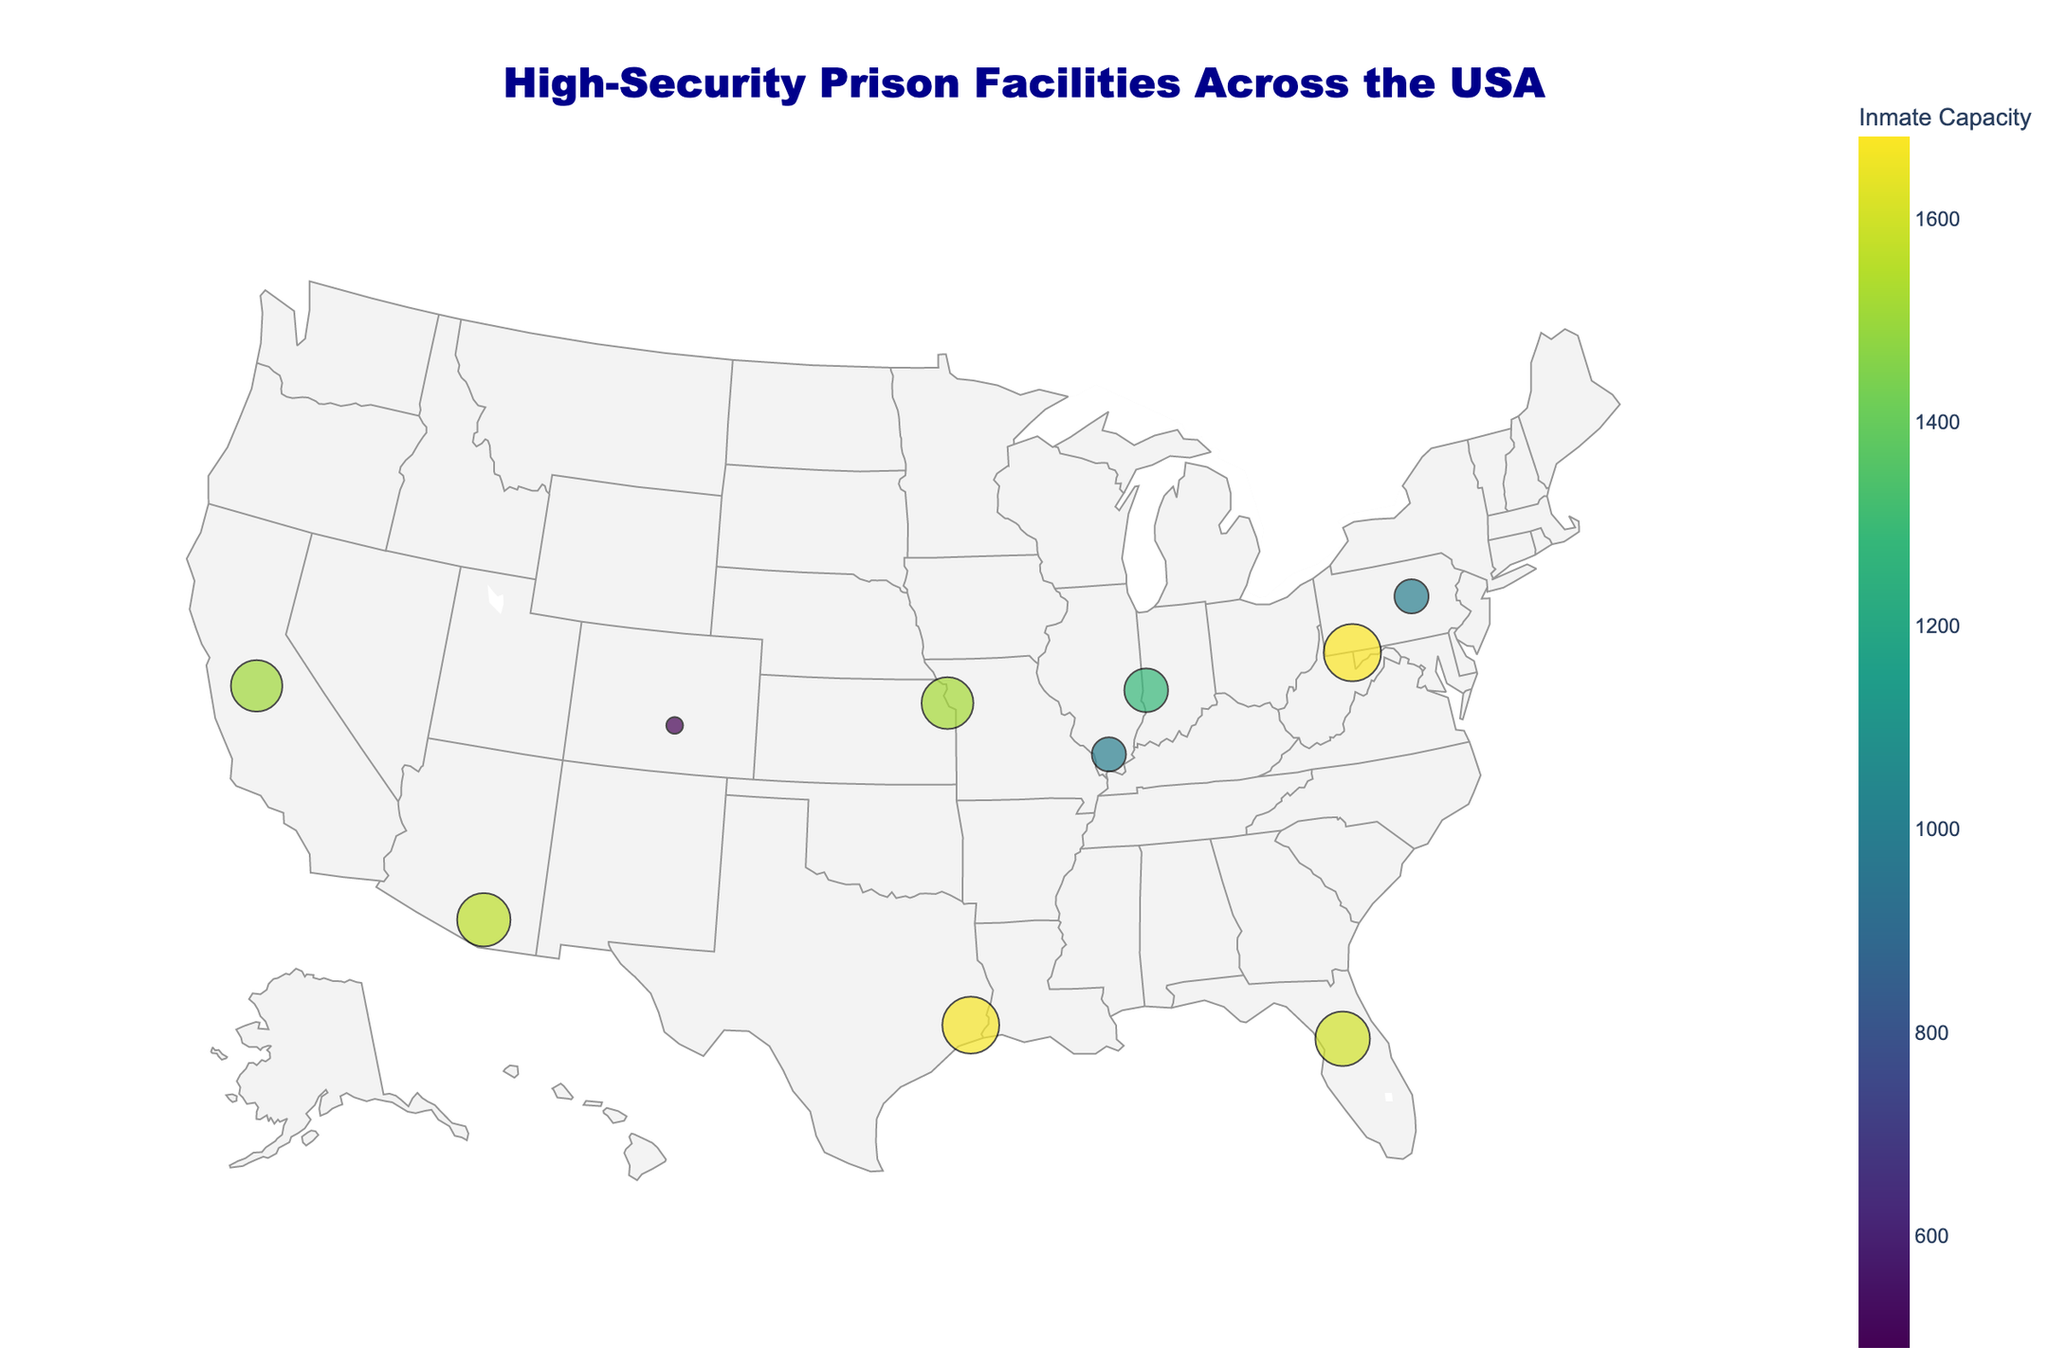Which facility has the highest inmate capacity? Identify the data points and find the one with the highest marker size along with the capacity value shown in the legend.
Answer: FCI Beaumont, Texas What's the average inmate capacity of the high-security level facilities? There are six high-security facilities: USP Terre Haute (1282), USP Atwater (1508), USP Lewisburg (1000), USP Coleman (1600), USP Hazelton (1680), USP Tucson (1564). Add the capacities and divide by the number of facilities: (1282 + 1508 + 1000 + 1600 + 1680 + 1564) / 6.
Answer: 1511 Which facility is located in Colorado? Find the data point in Colorado based on the geographic location and read the label.
Answer: ADX Florence Which facility is closest to the central USA? Visually identify the facility located closest to the central region of the USA on the map.
Answer: USP Leavenworth, Kansas How many facilities have an inmate capacity greater than 1500? Count the number of data points where the inmate capacity is greater than 1500 based on the size and color of the markers.
Answer: 5 What’s the total inmate capacity for all the facilities combined? Sum the inmate capacities for all facilities: 490 + 1282 + 1518 + 1508 + 1000 + 1000 + 1668 + 1600 + 1680 + 1564.
Answer: 14310 Compare the inmate capacity between USP Leavenworth and USP Hazelton. Which is larger? Check the values for both USP Leavenworth (1518) and USP Hazelton (1680) and compare them.
Answer: USP Hazelton Which facility is in a state starting with 'F'? Identify the data point located in a state starting with 'F' based on the labels and geographic location.
Answer: USP Coleman, Florida What’s the security level of the facility with the smallest inmate capacity? Find the smallest inmate capacity (490 at ADX Florence) and look at its security level.
Answer: Supermax How many facilities are there in total? Count the total number of data points (markers) on the map.
Answer: 10 